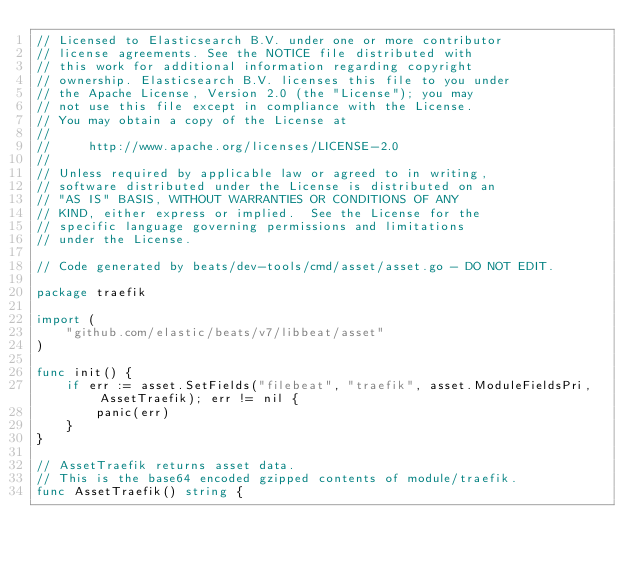<code> <loc_0><loc_0><loc_500><loc_500><_Go_>// Licensed to Elasticsearch B.V. under one or more contributor
// license agreements. See the NOTICE file distributed with
// this work for additional information regarding copyright
// ownership. Elasticsearch B.V. licenses this file to you under
// the Apache License, Version 2.0 (the "License"); you may
// not use this file except in compliance with the License.
// You may obtain a copy of the License at
//
//     http://www.apache.org/licenses/LICENSE-2.0
//
// Unless required by applicable law or agreed to in writing,
// software distributed under the License is distributed on an
// "AS IS" BASIS, WITHOUT WARRANTIES OR CONDITIONS OF ANY
// KIND, either express or implied.  See the License for the
// specific language governing permissions and limitations
// under the License.

// Code generated by beats/dev-tools/cmd/asset/asset.go - DO NOT EDIT.

package traefik

import (
	"github.com/elastic/beats/v7/libbeat/asset"
)

func init() {
	if err := asset.SetFields("filebeat", "traefik", asset.ModuleFieldsPri, AssetTraefik); err != nil {
		panic(err)
	}
}

// AssetTraefik returns asset data.
// This is the base64 encoded gzipped contents of module/traefik.
func AssetTraefik() string {</code> 